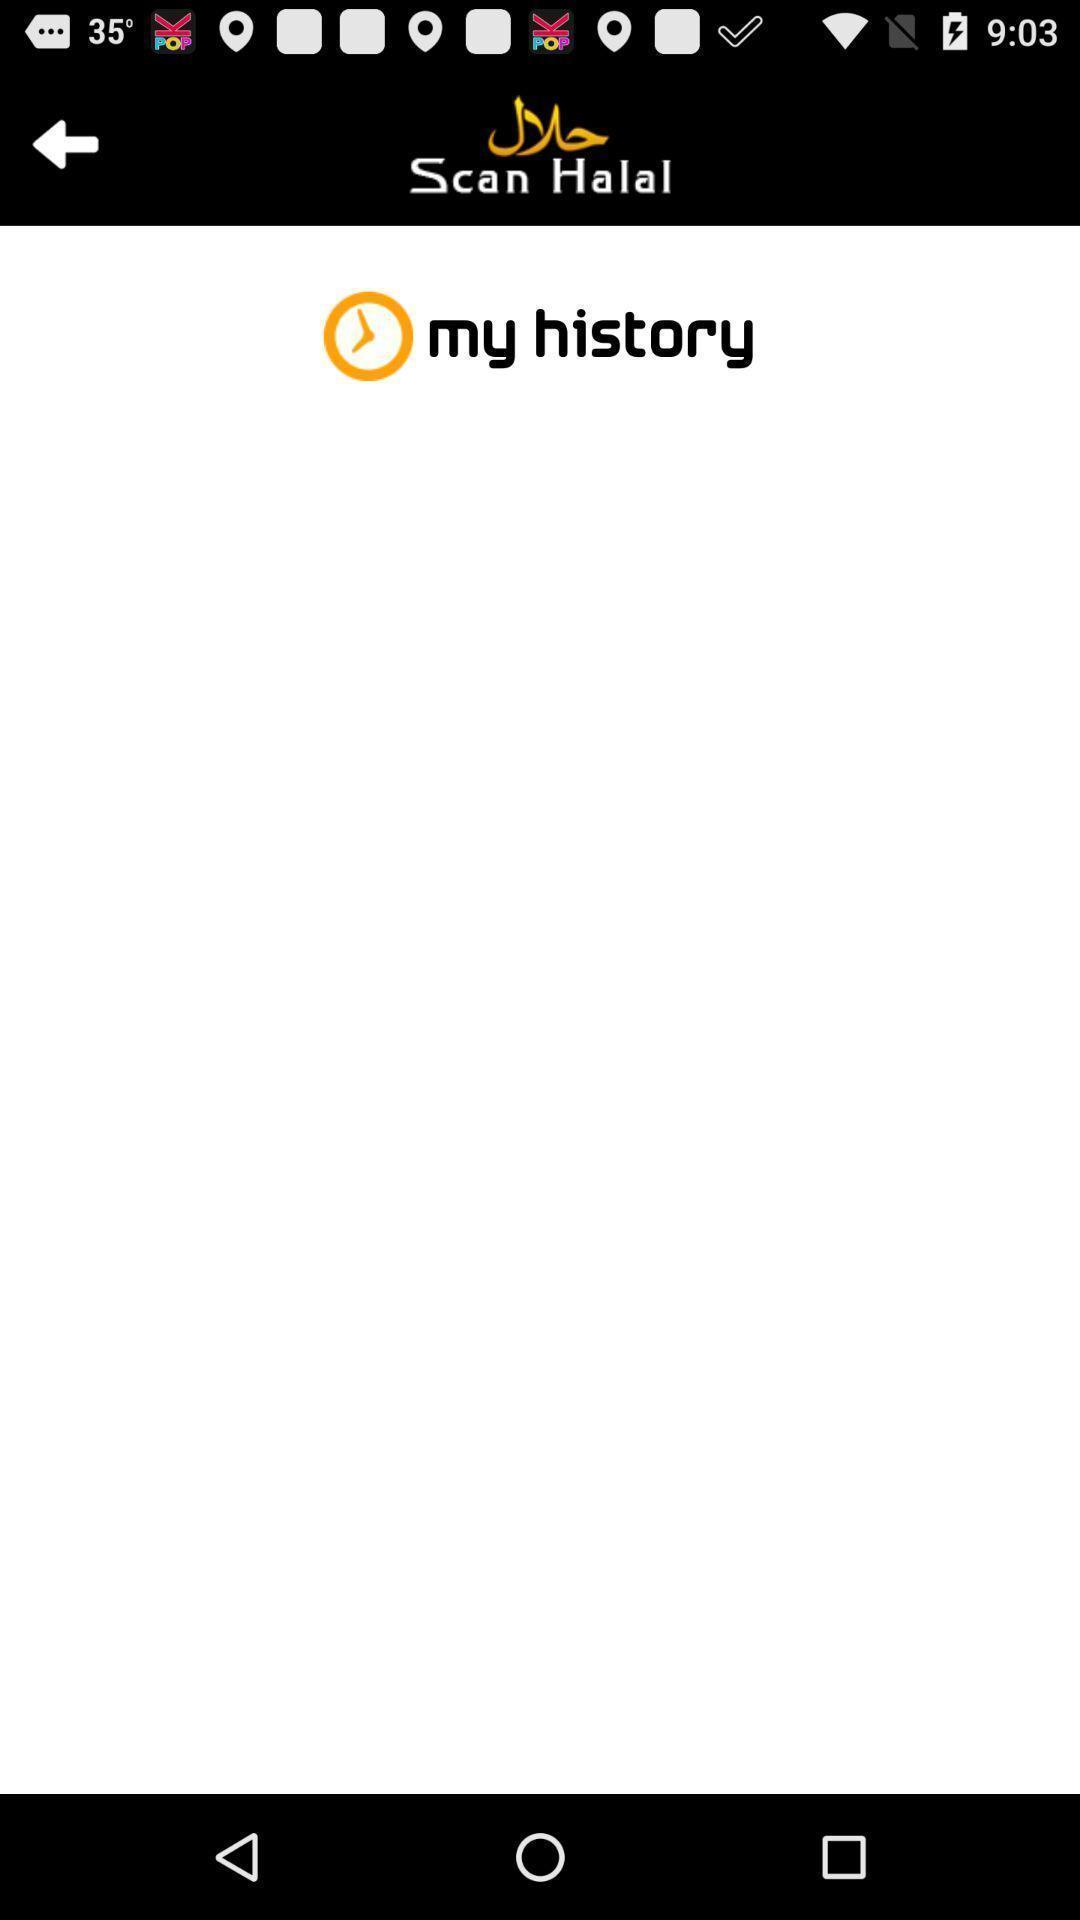Explain what's happening in this screen capture. Page of a food dietary app. 